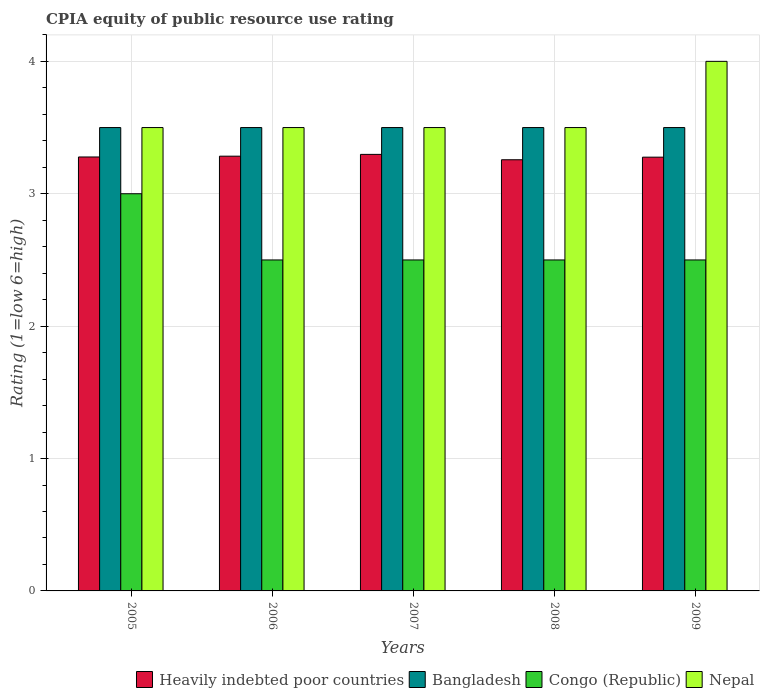How many different coloured bars are there?
Offer a very short reply. 4. How many groups of bars are there?
Make the answer very short. 5. Are the number of bars per tick equal to the number of legend labels?
Your answer should be very brief. Yes. How many bars are there on the 3rd tick from the left?
Keep it short and to the point. 4. How many bars are there on the 5th tick from the right?
Your response must be concise. 4. In how many cases, is the number of bars for a given year not equal to the number of legend labels?
Give a very brief answer. 0. Across all years, what is the maximum CPIA rating in Heavily indebted poor countries?
Your answer should be compact. 3.3. In which year was the CPIA rating in Congo (Republic) maximum?
Keep it short and to the point. 2005. In which year was the CPIA rating in Bangladesh minimum?
Ensure brevity in your answer.  2005. What is the total CPIA rating in Heavily indebted poor countries in the graph?
Your response must be concise. 16.39. What is the difference between the CPIA rating in Nepal in 2006 and that in 2008?
Make the answer very short. 0. What is the difference between the CPIA rating in Bangladesh in 2008 and the CPIA rating in Heavily indebted poor countries in 2009?
Make the answer very short. 0.22. In how many years, is the CPIA rating in Congo (Republic) greater than 3.8?
Make the answer very short. 0. Is the difference between the CPIA rating in Nepal in 2005 and 2009 greater than the difference between the CPIA rating in Bangladesh in 2005 and 2009?
Keep it short and to the point. No. What is the difference between the highest and the lowest CPIA rating in Heavily indebted poor countries?
Provide a succinct answer. 0.04. Is it the case that in every year, the sum of the CPIA rating in Congo (Republic) and CPIA rating in Bangladesh is greater than the sum of CPIA rating in Heavily indebted poor countries and CPIA rating in Nepal?
Ensure brevity in your answer.  No. What does the 1st bar from the right in 2007 represents?
Ensure brevity in your answer.  Nepal. How many bars are there?
Provide a short and direct response. 20. Are all the bars in the graph horizontal?
Offer a very short reply. No. Are the values on the major ticks of Y-axis written in scientific E-notation?
Your answer should be very brief. No. Where does the legend appear in the graph?
Provide a short and direct response. Bottom right. What is the title of the graph?
Provide a succinct answer. CPIA equity of public resource use rating. What is the label or title of the X-axis?
Your response must be concise. Years. What is the label or title of the Y-axis?
Give a very brief answer. Rating (1=low 6=high). What is the Rating (1=low 6=high) of Heavily indebted poor countries in 2005?
Make the answer very short. 3.28. What is the Rating (1=low 6=high) of Nepal in 2005?
Offer a terse response. 3.5. What is the Rating (1=low 6=high) of Heavily indebted poor countries in 2006?
Provide a succinct answer. 3.28. What is the Rating (1=low 6=high) in Heavily indebted poor countries in 2007?
Provide a short and direct response. 3.3. What is the Rating (1=low 6=high) in Bangladesh in 2007?
Ensure brevity in your answer.  3.5. What is the Rating (1=low 6=high) in Heavily indebted poor countries in 2008?
Ensure brevity in your answer.  3.26. What is the Rating (1=low 6=high) of Congo (Republic) in 2008?
Offer a very short reply. 2.5. What is the Rating (1=low 6=high) of Heavily indebted poor countries in 2009?
Make the answer very short. 3.28. What is the Rating (1=low 6=high) of Bangladesh in 2009?
Give a very brief answer. 3.5. What is the Rating (1=low 6=high) in Congo (Republic) in 2009?
Give a very brief answer. 2.5. Across all years, what is the maximum Rating (1=low 6=high) of Heavily indebted poor countries?
Provide a short and direct response. 3.3. Across all years, what is the minimum Rating (1=low 6=high) of Heavily indebted poor countries?
Your answer should be compact. 3.26. Across all years, what is the minimum Rating (1=low 6=high) in Congo (Republic)?
Your answer should be very brief. 2.5. Across all years, what is the minimum Rating (1=low 6=high) in Nepal?
Offer a very short reply. 3.5. What is the total Rating (1=low 6=high) of Heavily indebted poor countries in the graph?
Offer a very short reply. 16.39. What is the total Rating (1=low 6=high) in Nepal in the graph?
Offer a terse response. 18. What is the difference between the Rating (1=low 6=high) in Heavily indebted poor countries in 2005 and that in 2006?
Ensure brevity in your answer.  -0.01. What is the difference between the Rating (1=low 6=high) in Congo (Republic) in 2005 and that in 2006?
Provide a succinct answer. 0.5. What is the difference between the Rating (1=low 6=high) of Nepal in 2005 and that in 2006?
Your answer should be very brief. 0. What is the difference between the Rating (1=low 6=high) of Heavily indebted poor countries in 2005 and that in 2007?
Offer a very short reply. -0.02. What is the difference between the Rating (1=low 6=high) of Bangladesh in 2005 and that in 2007?
Give a very brief answer. 0. What is the difference between the Rating (1=low 6=high) in Nepal in 2005 and that in 2007?
Keep it short and to the point. 0. What is the difference between the Rating (1=low 6=high) of Heavily indebted poor countries in 2005 and that in 2008?
Offer a terse response. 0.02. What is the difference between the Rating (1=low 6=high) in Congo (Republic) in 2005 and that in 2008?
Provide a succinct answer. 0.5. What is the difference between the Rating (1=low 6=high) in Nepal in 2005 and that in 2008?
Provide a succinct answer. 0. What is the difference between the Rating (1=low 6=high) of Heavily indebted poor countries in 2005 and that in 2009?
Offer a terse response. 0. What is the difference between the Rating (1=low 6=high) of Congo (Republic) in 2005 and that in 2009?
Offer a terse response. 0.5. What is the difference between the Rating (1=low 6=high) of Heavily indebted poor countries in 2006 and that in 2007?
Ensure brevity in your answer.  -0.01. What is the difference between the Rating (1=low 6=high) of Congo (Republic) in 2006 and that in 2007?
Offer a terse response. 0. What is the difference between the Rating (1=low 6=high) in Nepal in 2006 and that in 2007?
Provide a short and direct response. 0. What is the difference between the Rating (1=low 6=high) of Heavily indebted poor countries in 2006 and that in 2008?
Keep it short and to the point. 0.03. What is the difference between the Rating (1=low 6=high) of Bangladesh in 2006 and that in 2008?
Offer a terse response. 0. What is the difference between the Rating (1=low 6=high) in Nepal in 2006 and that in 2008?
Provide a succinct answer. 0. What is the difference between the Rating (1=low 6=high) in Heavily indebted poor countries in 2006 and that in 2009?
Your answer should be compact. 0.01. What is the difference between the Rating (1=low 6=high) in Heavily indebted poor countries in 2007 and that in 2008?
Keep it short and to the point. 0.04. What is the difference between the Rating (1=low 6=high) in Bangladesh in 2007 and that in 2008?
Provide a succinct answer. 0. What is the difference between the Rating (1=low 6=high) of Congo (Republic) in 2007 and that in 2008?
Your answer should be very brief. 0. What is the difference between the Rating (1=low 6=high) of Heavily indebted poor countries in 2007 and that in 2009?
Provide a short and direct response. 0.02. What is the difference between the Rating (1=low 6=high) of Bangladesh in 2007 and that in 2009?
Ensure brevity in your answer.  0. What is the difference between the Rating (1=low 6=high) in Nepal in 2007 and that in 2009?
Ensure brevity in your answer.  -0.5. What is the difference between the Rating (1=low 6=high) in Heavily indebted poor countries in 2008 and that in 2009?
Make the answer very short. -0.02. What is the difference between the Rating (1=low 6=high) of Nepal in 2008 and that in 2009?
Provide a short and direct response. -0.5. What is the difference between the Rating (1=low 6=high) of Heavily indebted poor countries in 2005 and the Rating (1=low 6=high) of Bangladesh in 2006?
Your answer should be very brief. -0.22. What is the difference between the Rating (1=low 6=high) in Heavily indebted poor countries in 2005 and the Rating (1=low 6=high) in Congo (Republic) in 2006?
Your answer should be compact. 0.78. What is the difference between the Rating (1=low 6=high) in Heavily indebted poor countries in 2005 and the Rating (1=low 6=high) in Nepal in 2006?
Provide a succinct answer. -0.22. What is the difference between the Rating (1=low 6=high) in Congo (Republic) in 2005 and the Rating (1=low 6=high) in Nepal in 2006?
Provide a succinct answer. -0.5. What is the difference between the Rating (1=low 6=high) of Heavily indebted poor countries in 2005 and the Rating (1=low 6=high) of Bangladesh in 2007?
Your answer should be compact. -0.22. What is the difference between the Rating (1=low 6=high) of Heavily indebted poor countries in 2005 and the Rating (1=low 6=high) of Congo (Republic) in 2007?
Give a very brief answer. 0.78. What is the difference between the Rating (1=low 6=high) of Heavily indebted poor countries in 2005 and the Rating (1=low 6=high) of Nepal in 2007?
Your answer should be compact. -0.22. What is the difference between the Rating (1=low 6=high) in Heavily indebted poor countries in 2005 and the Rating (1=low 6=high) in Bangladesh in 2008?
Offer a terse response. -0.22. What is the difference between the Rating (1=low 6=high) of Heavily indebted poor countries in 2005 and the Rating (1=low 6=high) of Congo (Republic) in 2008?
Keep it short and to the point. 0.78. What is the difference between the Rating (1=low 6=high) in Heavily indebted poor countries in 2005 and the Rating (1=low 6=high) in Nepal in 2008?
Ensure brevity in your answer.  -0.22. What is the difference between the Rating (1=low 6=high) in Bangladesh in 2005 and the Rating (1=low 6=high) in Congo (Republic) in 2008?
Your answer should be compact. 1. What is the difference between the Rating (1=low 6=high) in Bangladesh in 2005 and the Rating (1=low 6=high) in Nepal in 2008?
Offer a very short reply. 0. What is the difference between the Rating (1=low 6=high) in Congo (Republic) in 2005 and the Rating (1=low 6=high) in Nepal in 2008?
Provide a succinct answer. -0.5. What is the difference between the Rating (1=low 6=high) in Heavily indebted poor countries in 2005 and the Rating (1=low 6=high) in Bangladesh in 2009?
Provide a succinct answer. -0.22. What is the difference between the Rating (1=low 6=high) of Heavily indebted poor countries in 2005 and the Rating (1=low 6=high) of Congo (Republic) in 2009?
Your answer should be compact. 0.78. What is the difference between the Rating (1=low 6=high) of Heavily indebted poor countries in 2005 and the Rating (1=low 6=high) of Nepal in 2009?
Make the answer very short. -0.72. What is the difference between the Rating (1=low 6=high) in Bangladesh in 2005 and the Rating (1=low 6=high) in Congo (Republic) in 2009?
Ensure brevity in your answer.  1. What is the difference between the Rating (1=low 6=high) in Congo (Republic) in 2005 and the Rating (1=low 6=high) in Nepal in 2009?
Your answer should be very brief. -1. What is the difference between the Rating (1=low 6=high) in Heavily indebted poor countries in 2006 and the Rating (1=low 6=high) in Bangladesh in 2007?
Provide a succinct answer. -0.22. What is the difference between the Rating (1=low 6=high) in Heavily indebted poor countries in 2006 and the Rating (1=low 6=high) in Congo (Republic) in 2007?
Offer a very short reply. 0.78. What is the difference between the Rating (1=low 6=high) in Heavily indebted poor countries in 2006 and the Rating (1=low 6=high) in Nepal in 2007?
Ensure brevity in your answer.  -0.22. What is the difference between the Rating (1=low 6=high) of Heavily indebted poor countries in 2006 and the Rating (1=low 6=high) of Bangladesh in 2008?
Your response must be concise. -0.22. What is the difference between the Rating (1=low 6=high) in Heavily indebted poor countries in 2006 and the Rating (1=low 6=high) in Congo (Republic) in 2008?
Keep it short and to the point. 0.78. What is the difference between the Rating (1=low 6=high) in Heavily indebted poor countries in 2006 and the Rating (1=low 6=high) in Nepal in 2008?
Keep it short and to the point. -0.22. What is the difference between the Rating (1=low 6=high) in Bangladesh in 2006 and the Rating (1=low 6=high) in Congo (Republic) in 2008?
Offer a terse response. 1. What is the difference between the Rating (1=low 6=high) of Bangladesh in 2006 and the Rating (1=low 6=high) of Nepal in 2008?
Make the answer very short. 0. What is the difference between the Rating (1=low 6=high) in Heavily indebted poor countries in 2006 and the Rating (1=low 6=high) in Bangladesh in 2009?
Offer a terse response. -0.22. What is the difference between the Rating (1=low 6=high) in Heavily indebted poor countries in 2006 and the Rating (1=low 6=high) in Congo (Republic) in 2009?
Provide a succinct answer. 0.78. What is the difference between the Rating (1=low 6=high) in Heavily indebted poor countries in 2006 and the Rating (1=low 6=high) in Nepal in 2009?
Ensure brevity in your answer.  -0.72. What is the difference between the Rating (1=low 6=high) of Bangladesh in 2006 and the Rating (1=low 6=high) of Congo (Republic) in 2009?
Offer a terse response. 1. What is the difference between the Rating (1=low 6=high) of Bangladesh in 2006 and the Rating (1=low 6=high) of Nepal in 2009?
Your answer should be compact. -0.5. What is the difference between the Rating (1=low 6=high) in Congo (Republic) in 2006 and the Rating (1=low 6=high) in Nepal in 2009?
Offer a terse response. -1.5. What is the difference between the Rating (1=low 6=high) of Heavily indebted poor countries in 2007 and the Rating (1=low 6=high) of Bangladesh in 2008?
Keep it short and to the point. -0.2. What is the difference between the Rating (1=low 6=high) of Heavily indebted poor countries in 2007 and the Rating (1=low 6=high) of Congo (Republic) in 2008?
Offer a very short reply. 0.8. What is the difference between the Rating (1=low 6=high) of Heavily indebted poor countries in 2007 and the Rating (1=low 6=high) of Nepal in 2008?
Give a very brief answer. -0.2. What is the difference between the Rating (1=low 6=high) of Bangladesh in 2007 and the Rating (1=low 6=high) of Congo (Republic) in 2008?
Your answer should be compact. 1. What is the difference between the Rating (1=low 6=high) in Congo (Republic) in 2007 and the Rating (1=low 6=high) in Nepal in 2008?
Provide a short and direct response. -1. What is the difference between the Rating (1=low 6=high) in Heavily indebted poor countries in 2007 and the Rating (1=low 6=high) in Bangladesh in 2009?
Provide a short and direct response. -0.2. What is the difference between the Rating (1=low 6=high) in Heavily indebted poor countries in 2007 and the Rating (1=low 6=high) in Congo (Republic) in 2009?
Provide a short and direct response. 0.8. What is the difference between the Rating (1=low 6=high) in Heavily indebted poor countries in 2007 and the Rating (1=low 6=high) in Nepal in 2009?
Offer a very short reply. -0.7. What is the difference between the Rating (1=low 6=high) of Bangladesh in 2007 and the Rating (1=low 6=high) of Congo (Republic) in 2009?
Make the answer very short. 1. What is the difference between the Rating (1=low 6=high) of Bangladesh in 2007 and the Rating (1=low 6=high) of Nepal in 2009?
Your answer should be compact. -0.5. What is the difference between the Rating (1=low 6=high) of Heavily indebted poor countries in 2008 and the Rating (1=low 6=high) of Bangladesh in 2009?
Offer a terse response. -0.24. What is the difference between the Rating (1=low 6=high) in Heavily indebted poor countries in 2008 and the Rating (1=low 6=high) in Congo (Republic) in 2009?
Your answer should be very brief. 0.76. What is the difference between the Rating (1=low 6=high) of Heavily indebted poor countries in 2008 and the Rating (1=low 6=high) of Nepal in 2009?
Provide a succinct answer. -0.74. What is the difference between the Rating (1=low 6=high) in Bangladesh in 2008 and the Rating (1=low 6=high) in Nepal in 2009?
Your response must be concise. -0.5. What is the difference between the Rating (1=low 6=high) in Congo (Republic) in 2008 and the Rating (1=low 6=high) in Nepal in 2009?
Provide a succinct answer. -1.5. What is the average Rating (1=low 6=high) of Heavily indebted poor countries per year?
Make the answer very short. 3.28. What is the average Rating (1=low 6=high) of Bangladesh per year?
Give a very brief answer. 3.5. What is the average Rating (1=low 6=high) in Congo (Republic) per year?
Ensure brevity in your answer.  2.6. What is the average Rating (1=low 6=high) in Nepal per year?
Keep it short and to the point. 3.6. In the year 2005, what is the difference between the Rating (1=low 6=high) in Heavily indebted poor countries and Rating (1=low 6=high) in Bangladesh?
Provide a short and direct response. -0.22. In the year 2005, what is the difference between the Rating (1=low 6=high) of Heavily indebted poor countries and Rating (1=low 6=high) of Congo (Republic)?
Give a very brief answer. 0.28. In the year 2005, what is the difference between the Rating (1=low 6=high) of Heavily indebted poor countries and Rating (1=low 6=high) of Nepal?
Offer a very short reply. -0.22. In the year 2005, what is the difference between the Rating (1=low 6=high) of Bangladesh and Rating (1=low 6=high) of Congo (Republic)?
Your response must be concise. 0.5. In the year 2006, what is the difference between the Rating (1=low 6=high) in Heavily indebted poor countries and Rating (1=low 6=high) in Bangladesh?
Keep it short and to the point. -0.22. In the year 2006, what is the difference between the Rating (1=low 6=high) of Heavily indebted poor countries and Rating (1=low 6=high) of Congo (Republic)?
Offer a very short reply. 0.78. In the year 2006, what is the difference between the Rating (1=low 6=high) in Heavily indebted poor countries and Rating (1=low 6=high) in Nepal?
Offer a terse response. -0.22. In the year 2006, what is the difference between the Rating (1=low 6=high) in Congo (Republic) and Rating (1=low 6=high) in Nepal?
Provide a succinct answer. -1. In the year 2007, what is the difference between the Rating (1=low 6=high) of Heavily indebted poor countries and Rating (1=low 6=high) of Bangladesh?
Your response must be concise. -0.2. In the year 2007, what is the difference between the Rating (1=low 6=high) of Heavily indebted poor countries and Rating (1=low 6=high) of Congo (Republic)?
Keep it short and to the point. 0.8. In the year 2007, what is the difference between the Rating (1=low 6=high) in Heavily indebted poor countries and Rating (1=low 6=high) in Nepal?
Ensure brevity in your answer.  -0.2. In the year 2007, what is the difference between the Rating (1=low 6=high) of Bangladesh and Rating (1=low 6=high) of Nepal?
Provide a short and direct response. 0. In the year 2008, what is the difference between the Rating (1=low 6=high) of Heavily indebted poor countries and Rating (1=low 6=high) of Bangladesh?
Offer a very short reply. -0.24. In the year 2008, what is the difference between the Rating (1=low 6=high) of Heavily indebted poor countries and Rating (1=low 6=high) of Congo (Republic)?
Provide a succinct answer. 0.76. In the year 2008, what is the difference between the Rating (1=low 6=high) in Heavily indebted poor countries and Rating (1=low 6=high) in Nepal?
Ensure brevity in your answer.  -0.24. In the year 2008, what is the difference between the Rating (1=low 6=high) of Bangladesh and Rating (1=low 6=high) of Nepal?
Your answer should be compact. 0. In the year 2009, what is the difference between the Rating (1=low 6=high) in Heavily indebted poor countries and Rating (1=low 6=high) in Bangladesh?
Give a very brief answer. -0.22. In the year 2009, what is the difference between the Rating (1=low 6=high) of Heavily indebted poor countries and Rating (1=low 6=high) of Congo (Republic)?
Give a very brief answer. 0.78. In the year 2009, what is the difference between the Rating (1=low 6=high) in Heavily indebted poor countries and Rating (1=low 6=high) in Nepal?
Your answer should be very brief. -0.72. In the year 2009, what is the difference between the Rating (1=low 6=high) of Congo (Republic) and Rating (1=low 6=high) of Nepal?
Your answer should be very brief. -1.5. What is the ratio of the Rating (1=low 6=high) of Heavily indebted poor countries in 2005 to that in 2006?
Your answer should be very brief. 1. What is the ratio of the Rating (1=low 6=high) in Bangladesh in 2005 to that in 2007?
Your answer should be compact. 1. What is the ratio of the Rating (1=low 6=high) in Congo (Republic) in 2005 to that in 2007?
Offer a very short reply. 1.2. What is the ratio of the Rating (1=low 6=high) of Nepal in 2005 to that in 2007?
Offer a very short reply. 1. What is the ratio of the Rating (1=low 6=high) in Bangladesh in 2005 to that in 2008?
Offer a very short reply. 1. What is the ratio of the Rating (1=low 6=high) of Nepal in 2005 to that in 2008?
Your answer should be very brief. 1. What is the ratio of the Rating (1=low 6=high) of Nepal in 2005 to that in 2009?
Give a very brief answer. 0.88. What is the ratio of the Rating (1=low 6=high) in Congo (Republic) in 2006 to that in 2007?
Offer a very short reply. 1. What is the ratio of the Rating (1=low 6=high) in Nepal in 2006 to that in 2007?
Make the answer very short. 1. What is the ratio of the Rating (1=low 6=high) of Heavily indebted poor countries in 2006 to that in 2008?
Make the answer very short. 1.01. What is the ratio of the Rating (1=low 6=high) in Bangladesh in 2006 to that in 2008?
Give a very brief answer. 1. What is the ratio of the Rating (1=low 6=high) of Congo (Republic) in 2006 to that in 2008?
Ensure brevity in your answer.  1. What is the ratio of the Rating (1=low 6=high) of Heavily indebted poor countries in 2006 to that in 2009?
Provide a short and direct response. 1. What is the ratio of the Rating (1=low 6=high) of Nepal in 2006 to that in 2009?
Provide a succinct answer. 0.88. What is the ratio of the Rating (1=low 6=high) of Heavily indebted poor countries in 2007 to that in 2008?
Offer a very short reply. 1.01. What is the ratio of the Rating (1=low 6=high) of Congo (Republic) in 2007 to that in 2008?
Give a very brief answer. 1. What is the ratio of the Rating (1=low 6=high) in Nepal in 2007 to that in 2008?
Your response must be concise. 1. What is the ratio of the Rating (1=low 6=high) of Heavily indebted poor countries in 2007 to that in 2009?
Give a very brief answer. 1.01. What is the ratio of the Rating (1=low 6=high) of Bangladesh in 2007 to that in 2009?
Keep it short and to the point. 1. What is the ratio of the Rating (1=low 6=high) in Heavily indebted poor countries in 2008 to that in 2009?
Ensure brevity in your answer.  0.99. What is the difference between the highest and the second highest Rating (1=low 6=high) of Heavily indebted poor countries?
Ensure brevity in your answer.  0.01. What is the difference between the highest and the second highest Rating (1=low 6=high) of Congo (Republic)?
Offer a very short reply. 0.5. What is the difference between the highest and the second highest Rating (1=low 6=high) in Nepal?
Your answer should be compact. 0.5. What is the difference between the highest and the lowest Rating (1=low 6=high) of Heavily indebted poor countries?
Give a very brief answer. 0.04. What is the difference between the highest and the lowest Rating (1=low 6=high) in Nepal?
Provide a short and direct response. 0.5. 